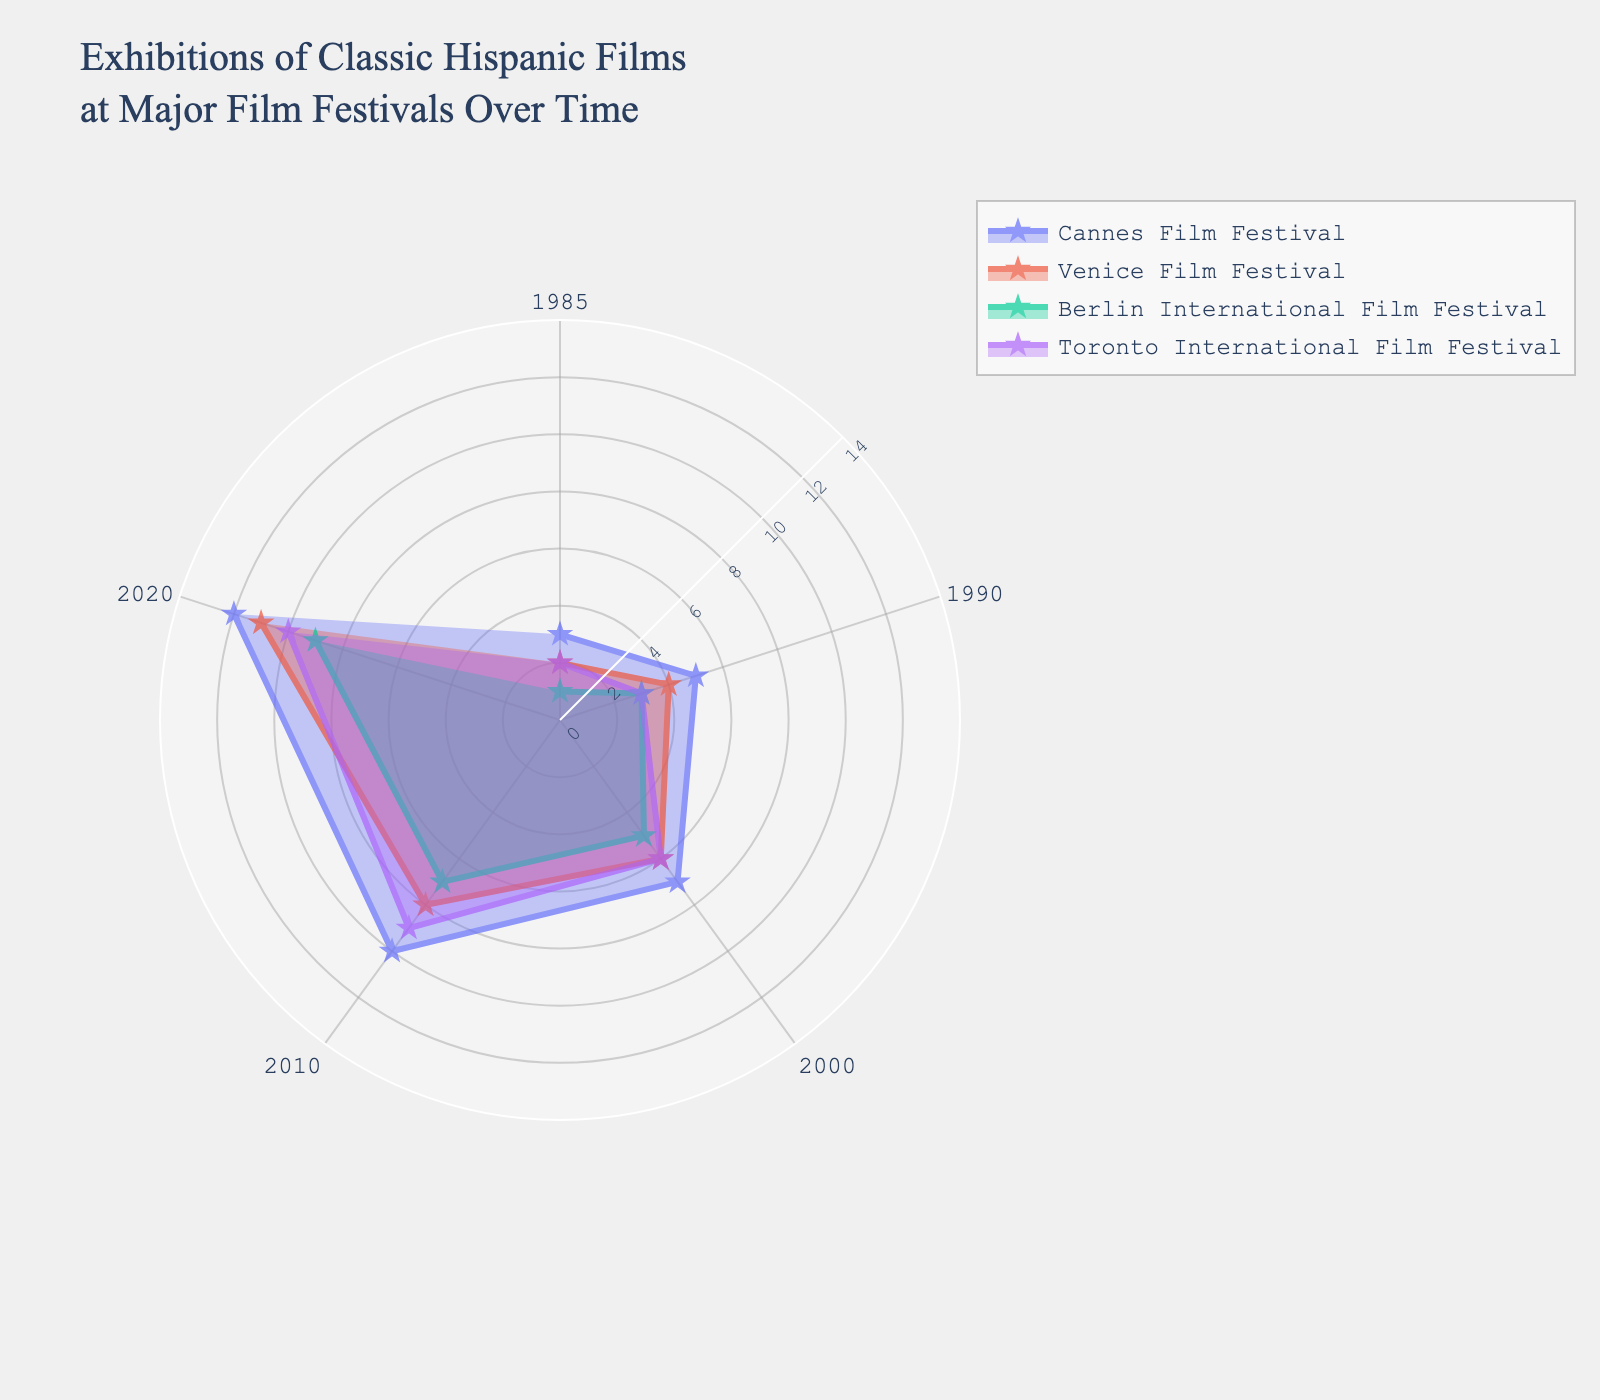What is the title of the figure? The title is usually located at the top of the plot, providing a summary of what the chart illustrates. In this case, the title is "Exhibitions of Classic Hispanic Films at Major Film Festivals Over Time."
Answer: Exhibitions of Classic Hispanic Films at Major Film Festivals Over Time How many data points are there for each film festival? We need to count the number of years each film festival has data points in the plot. There are values for five years: 1985, 1990, 2000, 2010, and 2020. So, each film festival has 5 data points.
Answer: 5 Which festival exhibited the most classic Hispanic films in 2020? In the plot, locate the data point corresponding to 2020 for each film festival and compare them. The Cannes Film Festival exhibited the most films with a count of 12 in 2020.
Answer: Cannes Film Festival What is the general trend of the number of classic Hispanic films exhibited over time across all festivals? Observing the plot, one can see that the number of classic Hispanic films exhibited by each festival generally increases over the years, indicating a positive trend.
Answer: Increasing Between the Venice Film Festival and the Berlin International Film Festival, which had fewer exhibitions in 1985? Look at the data points for 1985 for both festivals. The Venice Film Festival had 2 exhibitions while the Berlin International Film Festival had 1. Therefore, the Berlin International Film Festival had fewer exhibitions in 1985.
Answer: Berlin International Film Festival How many more films did the Cannes Film Festival exhibit in 2010 compared to the Berlin International Film Festival? Identify the number of films exhibited by each festival in 2010. Cannes Film Festival exhibited 10, and Berlin International Film Festival exhibited 7. The difference is 10 - 7 = 3.
Answer: 3 Which festival shows the smallest increase in the number of films exhibited between 1990 and 2000? Calculate the difference between the 1990 and 2000 data points for each festival. The increases are as follows: Cannes (2), Venice (2), Berlin (2), Toronto (3). The smallest increase is the same for Cannes, Venice, and Berlin, at 2 films.
Answer: Cannes, Venice, Berlin What is the average number of films exhibited by the Toronto International Film Festival in 1985, 1990, and 2000? Sum the data points for the specified years (2, 3, 6) and divide by the number of years (3). (2 + 3 + 6) / 3 = 11 / 3 = 3.67
Answer: 3.67 Which film festival showed the greatest relative increase in the number of films exhibited from 2000 to 2010? Calculate the relative increase as a percentage for each festival between 2000 and 2010: Cannes ((10-7)/7) * 100 = 42.86%, Venice ((8-6)/6) * 100 = 33.33%, Berlin ((7-5)/5) * 100 = 40%, Toronto ((9-6)/6) * 100 = 50%. The Toronto International Film Festival has the highest relative increase at 50%.
Answer: Toronto International Film Festival 